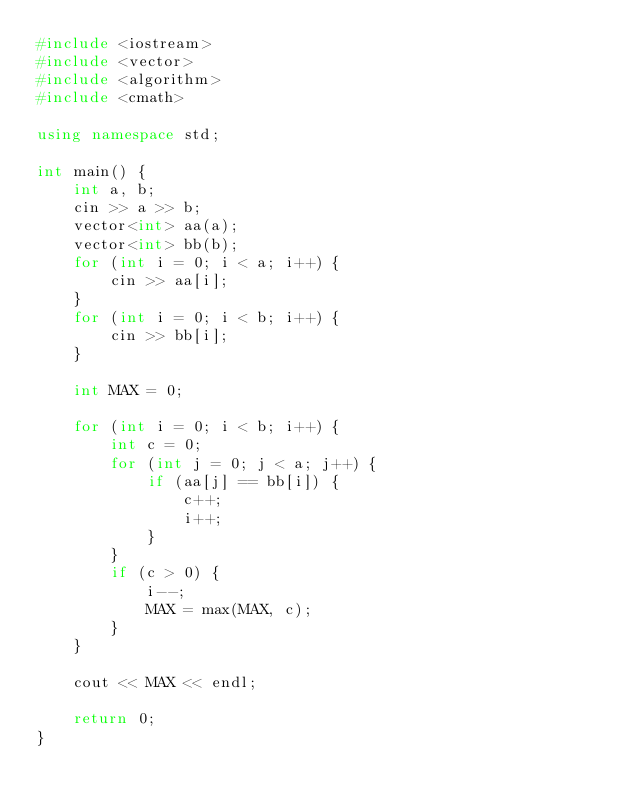<code> <loc_0><loc_0><loc_500><loc_500><_C++_>#include <iostream>
#include <vector>
#include <algorithm>
#include <cmath>

using namespace std;

int main() {
	int a, b;
	cin >> a >> b;
	vector<int> aa(a);
	vector<int> bb(b);
	for (int i = 0; i < a; i++) {
		cin >> aa[i];
	}
	for (int i = 0; i < b; i++) {
		cin >> bb[i];
	}

	int MAX = 0;

	for (int i = 0; i < b; i++) {
		int c = 0;
		for (int j = 0; j < a; j++) {
			if (aa[j] == bb[i]) {
				c++;
				i++;
			}
		}
		if (c > 0) {
			i--;
			MAX = max(MAX, c);
		}
	}

	cout << MAX << endl;

	return 0;
}</code> 